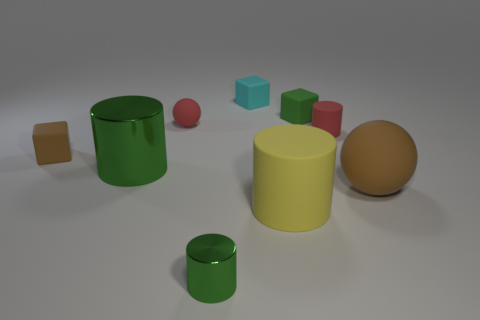What number of tiny matte things are the same color as the big sphere?
Offer a very short reply. 1. How big is the rubber cylinder in front of the big brown object?
Provide a succinct answer. Large. There is a brown object on the right side of the block that is on the left side of the small cyan cube; what shape is it?
Give a very brief answer. Sphere. There is a small metallic cylinder on the right side of the green shiny thing behind the tiny green metal cylinder; how many large yellow rubber cylinders are left of it?
Your answer should be compact. 0. Are there fewer big matte spheres left of the cyan cube than green matte cylinders?
Provide a short and direct response. No. There is a red matte thing that is right of the tiny cyan rubber block; what shape is it?
Make the answer very short. Cylinder. What shape is the brown thing that is on the right side of the matte sphere that is to the left of the small red object that is right of the big matte cylinder?
Offer a terse response. Sphere. What number of things are either big metallic cylinders or big brown balls?
Make the answer very short. 2. Is the shape of the green metallic thing behind the brown rubber sphere the same as the tiny red matte thing right of the cyan matte thing?
Your answer should be compact. Yes. How many matte objects are both in front of the red matte cylinder and on the left side of the small metal cylinder?
Your answer should be compact. 1. 